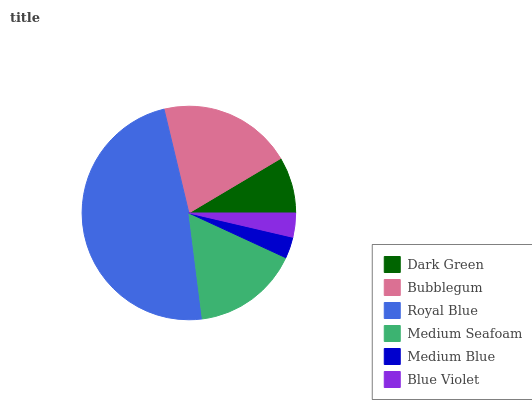Is Medium Blue the minimum?
Answer yes or no. Yes. Is Royal Blue the maximum?
Answer yes or no. Yes. Is Bubblegum the minimum?
Answer yes or no. No. Is Bubblegum the maximum?
Answer yes or no. No. Is Bubblegum greater than Dark Green?
Answer yes or no. Yes. Is Dark Green less than Bubblegum?
Answer yes or no. Yes. Is Dark Green greater than Bubblegum?
Answer yes or no. No. Is Bubblegum less than Dark Green?
Answer yes or no. No. Is Medium Seafoam the high median?
Answer yes or no. Yes. Is Dark Green the low median?
Answer yes or no. Yes. Is Dark Green the high median?
Answer yes or no. No. Is Bubblegum the low median?
Answer yes or no. No. 